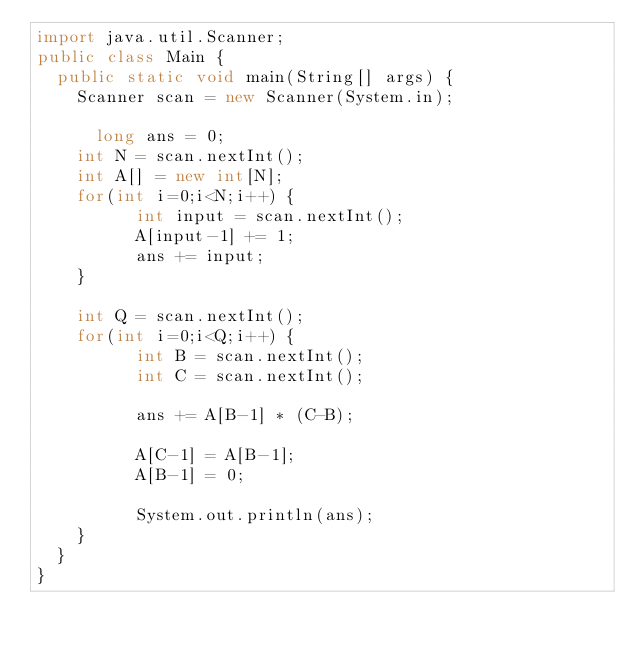<code> <loc_0><loc_0><loc_500><loc_500><_Java_>import java.util.Scanner;
public class Main {
	public static void main(String[] args) {
		Scanner scan = new Scanner(System.in);
		
     	long ans = 0;
		int N = scan.nextInt();
		int A[] = new int[N];
		for(int i=0;i<N;i++) {
          int input = scan.nextInt();
          A[input-1] += 1;
          ans += input;
		}
		
		int Q = scan.nextInt();
		for(int i=0;i<Q;i++) {
          int B = scan.nextInt();
          int C = scan.nextInt();
          
          ans += A[B-1] * (C-B);
          
          A[C-1] = A[B-1];
          A[B-1] = 0;
          
          System.out.println(ans);
		}
	}
}</code> 